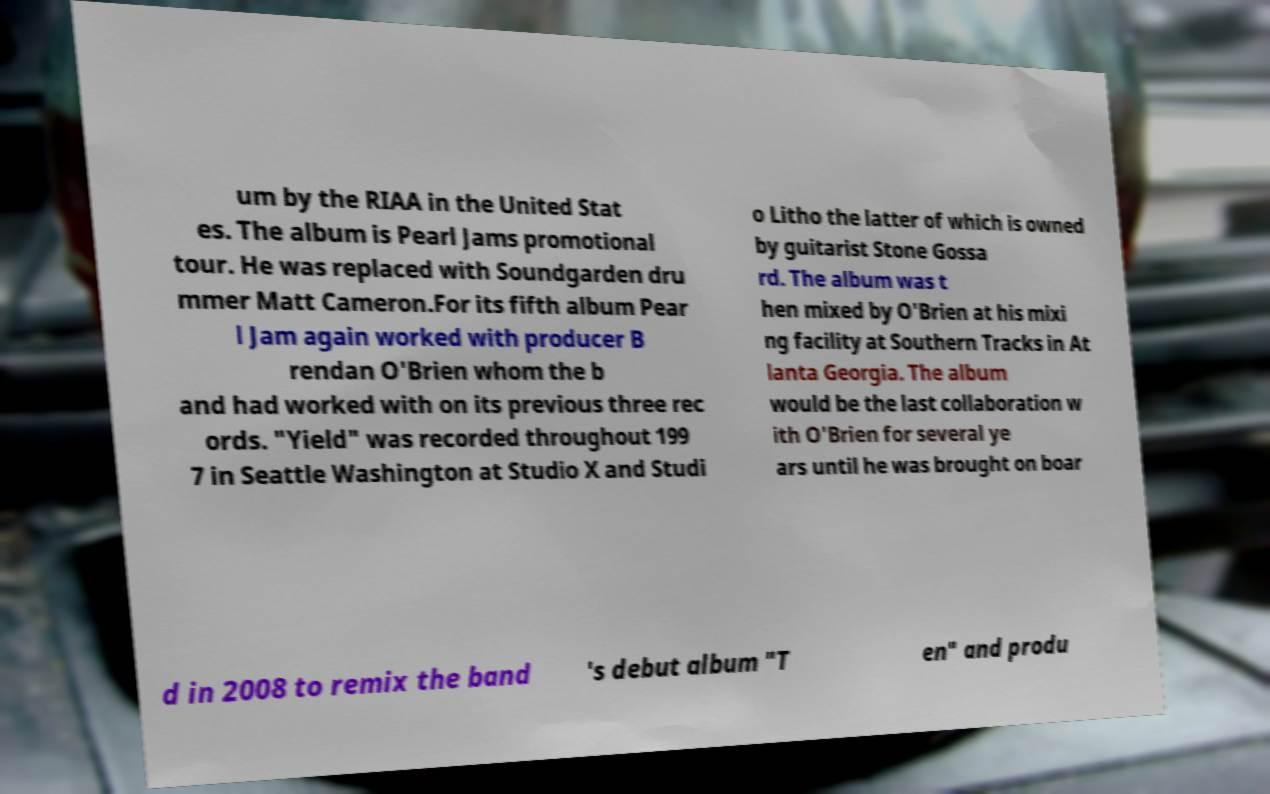Could you extract and type out the text from this image? um by the RIAA in the United Stat es. The album is Pearl Jams promotional tour. He was replaced with Soundgarden dru mmer Matt Cameron.For its fifth album Pear l Jam again worked with producer B rendan O'Brien whom the b and had worked with on its previous three rec ords. "Yield" was recorded throughout 199 7 in Seattle Washington at Studio X and Studi o Litho the latter of which is owned by guitarist Stone Gossa rd. The album was t hen mixed by O'Brien at his mixi ng facility at Southern Tracks in At lanta Georgia. The album would be the last collaboration w ith O'Brien for several ye ars until he was brought on boar d in 2008 to remix the band 's debut album "T en" and produ 